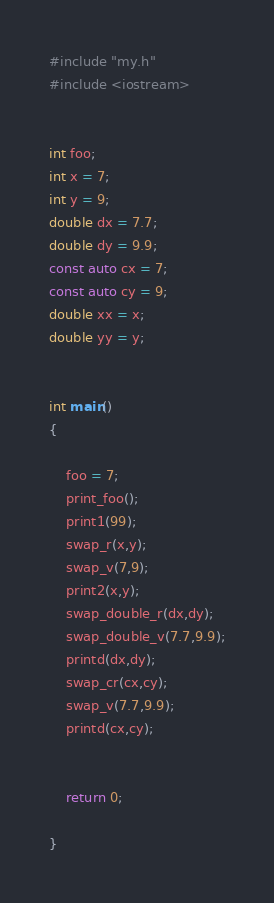<code> <loc_0><loc_0><loc_500><loc_500><_C++_>#include "my.h"
#include <iostream>


int foo;
int x = 7;
int y = 9;
double dx = 7.7;
double dy = 9.9;
const auto cx = 7;
const auto cy = 9;
double xx = x;
double yy = y;


int main()
{

	foo = 7;
	print_foo();
	print1(99);	
	swap_r(x,y);
	swap_v(7,9);
	print2(x,y);
	swap_double_r(dx,dy);
	swap_double_v(7.7,9.9);
	printd(dx,dy);
	swap_cr(cx,cy);
	swap_v(7.7,9.9);
	printd(cx,cy);
	

	return 0;

}

</code> 